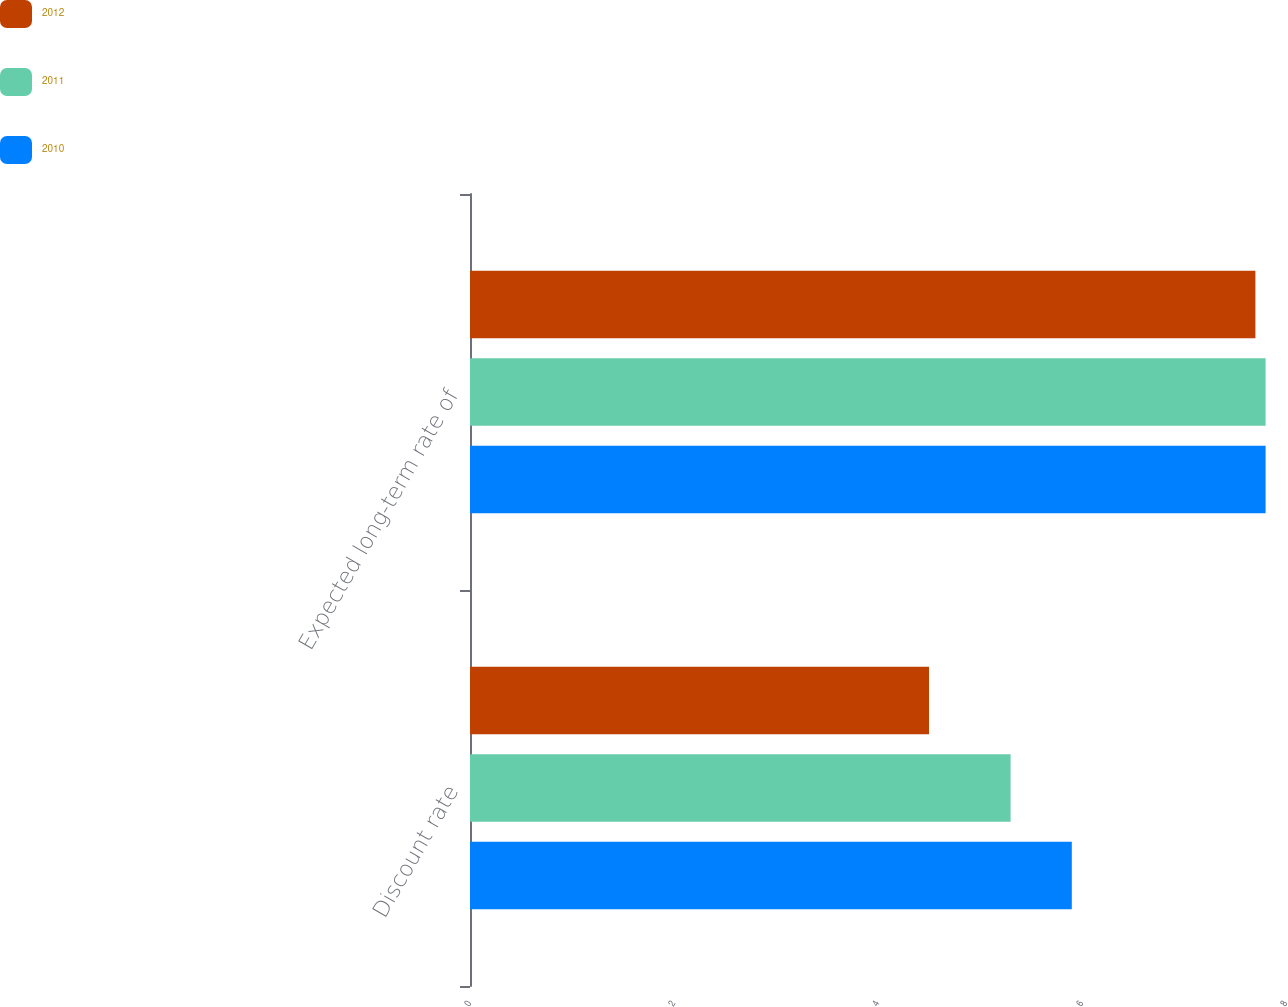<chart> <loc_0><loc_0><loc_500><loc_500><stacked_bar_chart><ecel><fcel>Discount rate<fcel>Expected long-term rate of<nl><fcel>2012<fcel>4.5<fcel>7.7<nl><fcel>2011<fcel>5.3<fcel>7.8<nl><fcel>2010<fcel>5.9<fcel>7.8<nl></chart> 